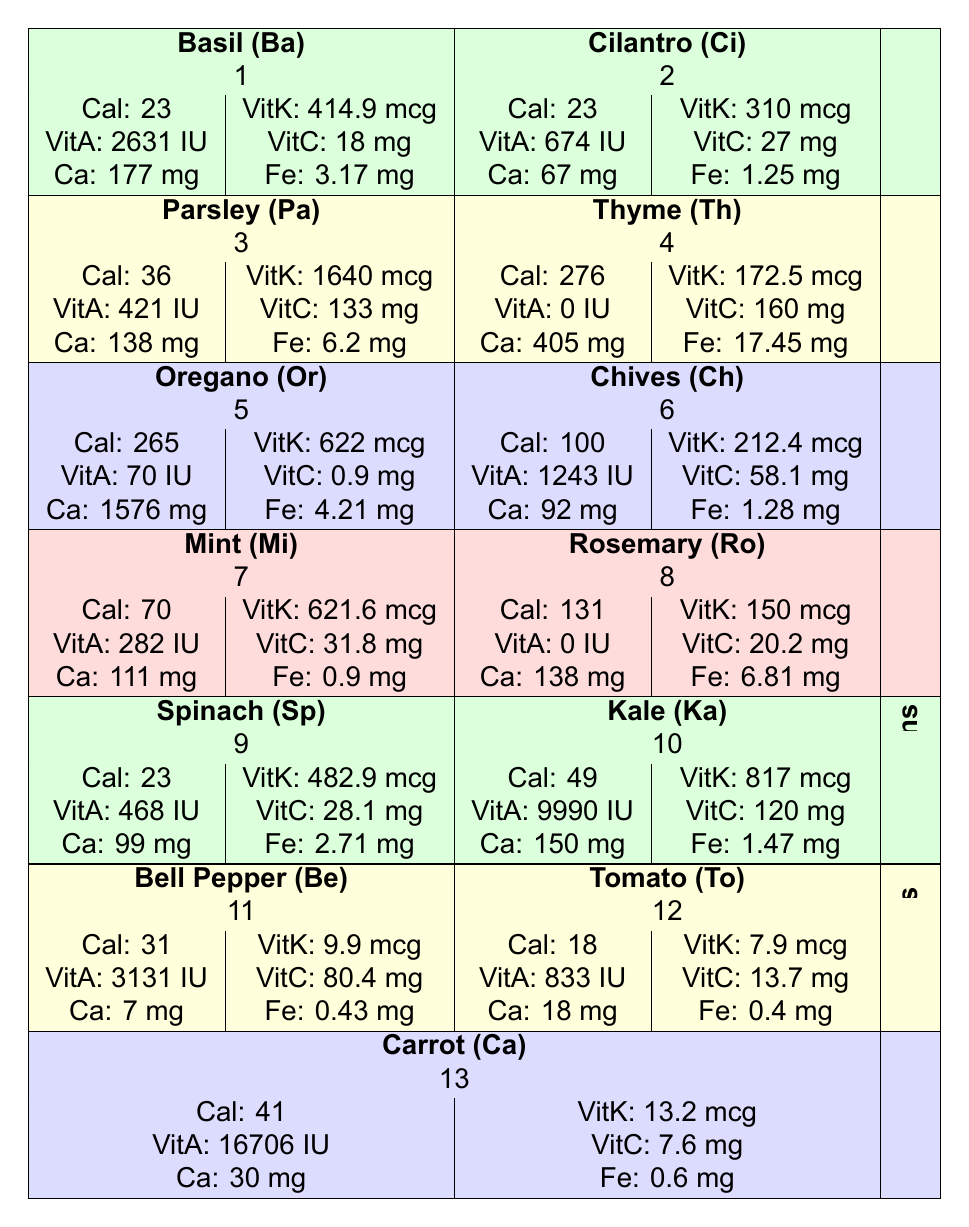What is the caloric content of Parsley? The table indicates that Parsley has a caloric content of 36.
Answer: 36 Which herb has the highest Vitamin K content? In the table, Parsley has the highest Vitamin K content listed as 1640 mcg, which is more than other herbs.
Answer: Parsley How many milligrams of Iron are present in Oregano? According to the table, Oregano contains 4.21 mg of Iron.
Answer: 4.21 mg What is the average Vitamin A content of Leafy Greens (Spinach and Kale)? Adding the Vitamin A of Spinach (468 IU) and Kale (9990 IU), we get 468 + 9990 = 10458 IU. To find the average, we divide by 2, which gives us 10458 / 2 = 5229 IU.
Answer: 5229 IU Does Mint contain more Vitamin C than Basil? Mint has 31.8 mg of Vitamin C while Basil has 18 mg. Since 31.8 mg is greater than 18 mg, this statement is true.
Answer: Yes Which has more Calcium, Bell Pepper or Tomato? Bell Pepper has 7 mg of Calcium and Tomato has 18 mg. Since 18 mg is greater than 7 mg, Tomato has more Calcium.
Answer: Tomato What is the total amount of Calories in Thyme and Chives combined? Thyme has 276 calories and Chives have 100 calories. Combining them gives us 276 + 100 = 376 calories.
Answer: 376 Is the Iron content of Kale greater than that of Spinach? Kale has an Iron content of 1.47 mg and Spinach has 2.71 mg. Since 1.47 mg is less than 2.71 mg, this statement is false.
Answer: No What is the difference in Vitamin K content between Oregano and Mint? Oregano has 622 mcg of Vitamin K and Mint has 621.6 mcg. The difference is 622 - 621.6 = 0.4 mcg.
Answer: 0.4 mcg 